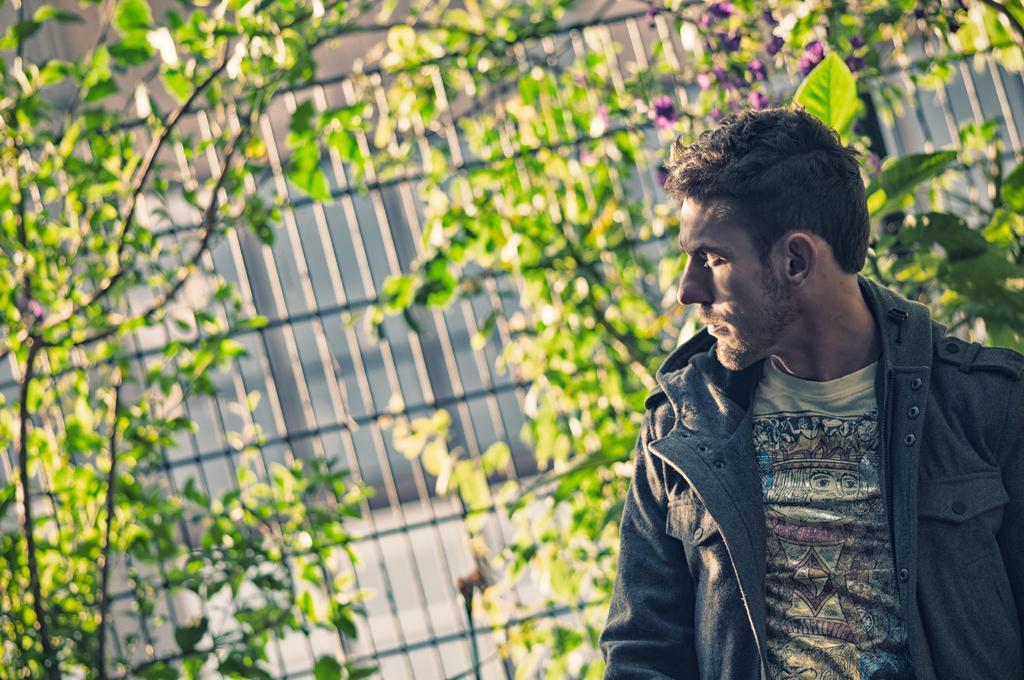Can you describe this image briefly? In this image, on the right there is a man, he wears a t shirt, jacket. In the background there are plants, iron grill, flowers. 